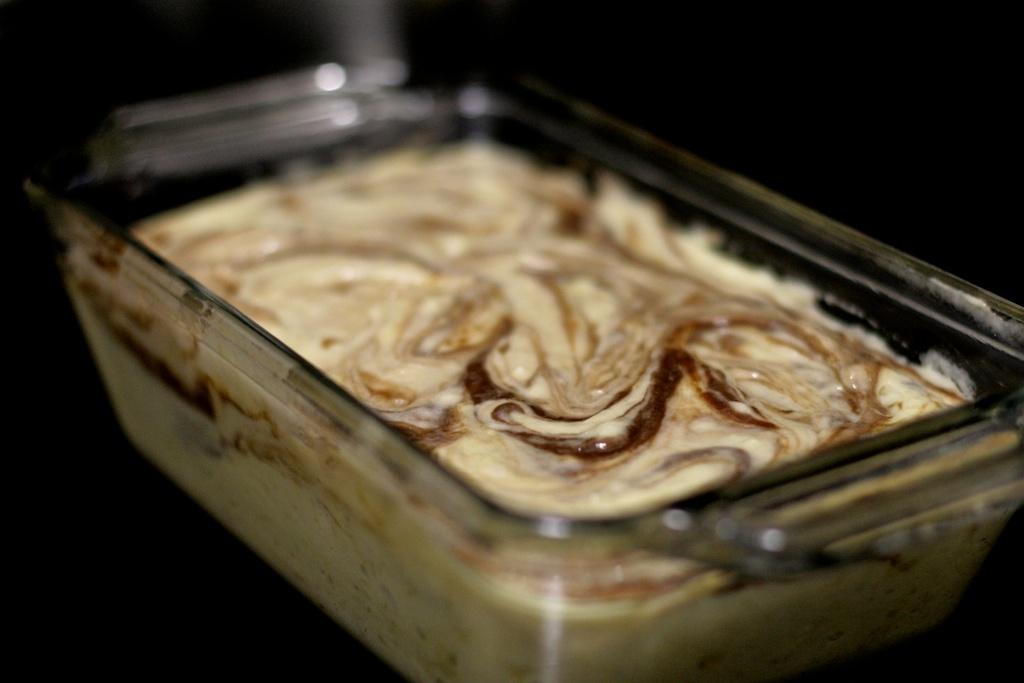What is the main subject of the image? There is a food item in the image. Can you describe the container in which the food item is placed? The food item is in a glass bowl. Can you tell me how many robins are perched on the door in the image? There is no door or robin present in the image; it only features a food item in a glass bowl. 